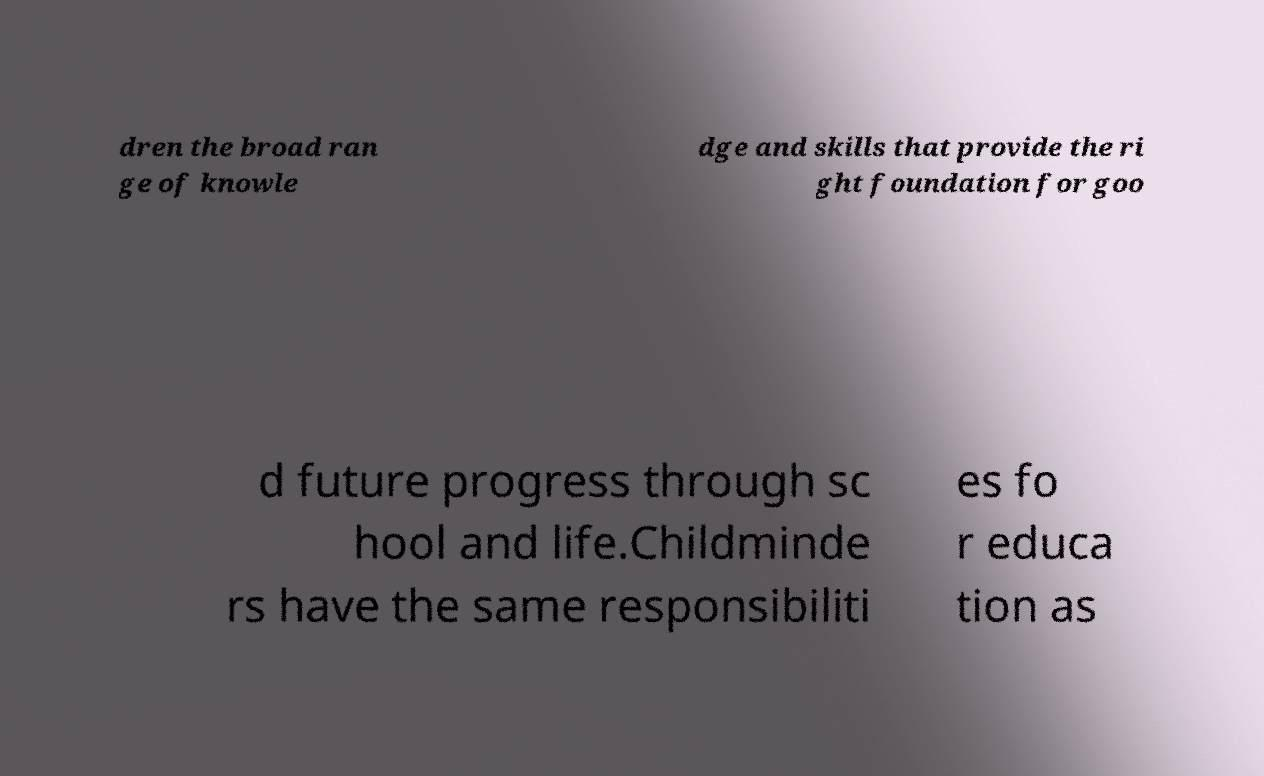There's text embedded in this image that I need extracted. Can you transcribe it verbatim? dren the broad ran ge of knowle dge and skills that provide the ri ght foundation for goo d future progress through sc hool and life.Childminde rs have the same responsibiliti es fo r educa tion as 